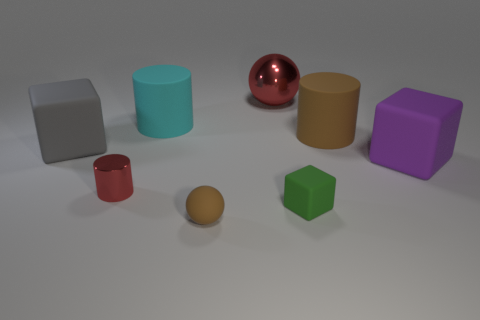Considering the arrangement of the objects, could this be an image used for a specific purpose? Yes, the arrangement of these objects with their distinct shapes and colors could be used for visual demonstrations, such as in a teaching material to explain geometry, color theory, or lighting in photography. 